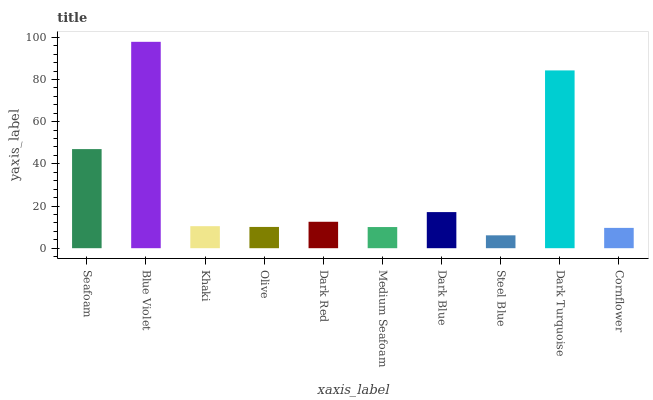Is Steel Blue the minimum?
Answer yes or no. Yes. Is Blue Violet the maximum?
Answer yes or no. Yes. Is Khaki the minimum?
Answer yes or no. No. Is Khaki the maximum?
Answer yes or no. No. Is Blue Violet greater than Khaki?
Answer yes or no. Yes. Is Khaki less than Blue Violet?
Answer yes or no. Yes. Is Khaki greater than Blue Violet?
Answer yes or no. No. Is Blue Violet less than Khaki?
Answer yes or no. No. Is Dark Red the high median?
Answer yes or no. Yes. Is Khaki the low median?
Answer yes or no. Yes. Is Cornflower the high median?
Answer yes or no. No. Is Olive the low median?
Answer yes or no. No. 